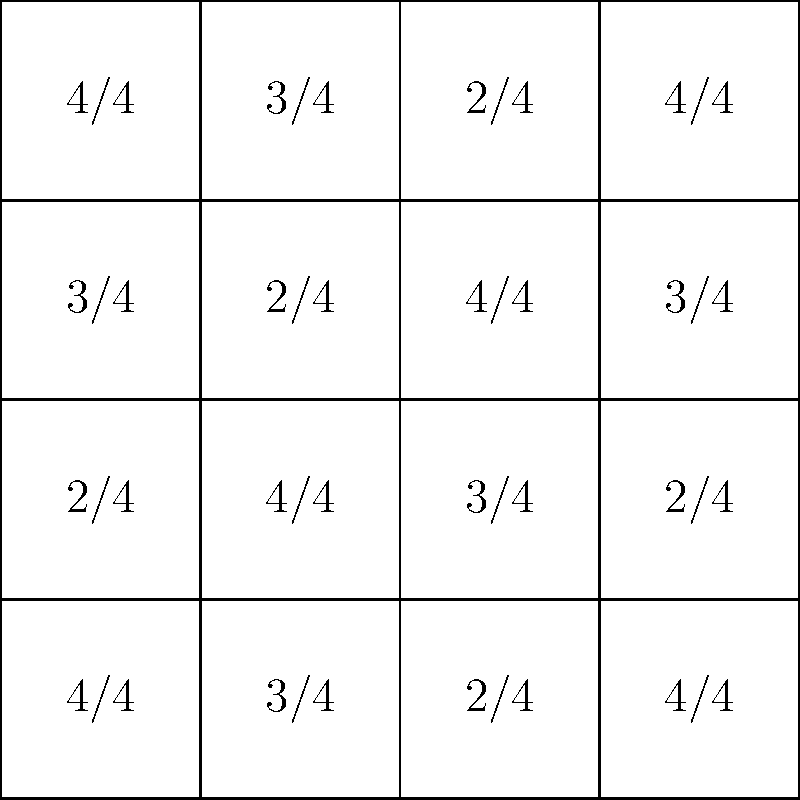Given the 4x4 grid of time signatures above, what is the order of the group formed by the rotational symmetries of this rhythmic pattern, and how might this insight be valuable for a music scout analyzing innovative compositions? To determine the order of the group formed by the rotational symmetries, we need to follow these steps:

1. Identify the rotational symmetries:
   - 0° rotation (identity)
   - 90° clockwise rotation
   - 180° rotation
   - 270° clockwise rotation (or 90° counterclockwise)

2. Verify that each rotation preserves the pattern:
   - 90° CW: 4/4 3/4 2/4 4/4 becomes 4/4 2/4 4/4 3/4 (top row)
   - 180°: 4/4 3/4 2/4 4/4 becomes 4/4 2/4 3/4 4/4 (top row)
   - 270° CW: 4/4 3/4 2/4 4/4 becomes 3/4 4/4 2/4 4/4 (top row)

3. Count the number of distinct rotations:
   There are 4 distinct rotations (including the identity rotation).

4. The order of the group is the number of elements in the group, which is 4.

For a music scout, this insight is valuable because:

a) It reveals the structural complexity of the composition, showing a high degree of symmetry.
b) It indicates a carefully crafted rhythmic pattern that may be aurally interesting when repeated or transformed.
c) Understanding these mathematical properties can help in identifying unique compositional techniques that set apart innovative artists.
d) It provides a framework for analyzing and comparing different rhythmic structures across various compositions and artists.
Answer: Order 4; valuable for identifying innovative compositional techniques and structural complexity. 